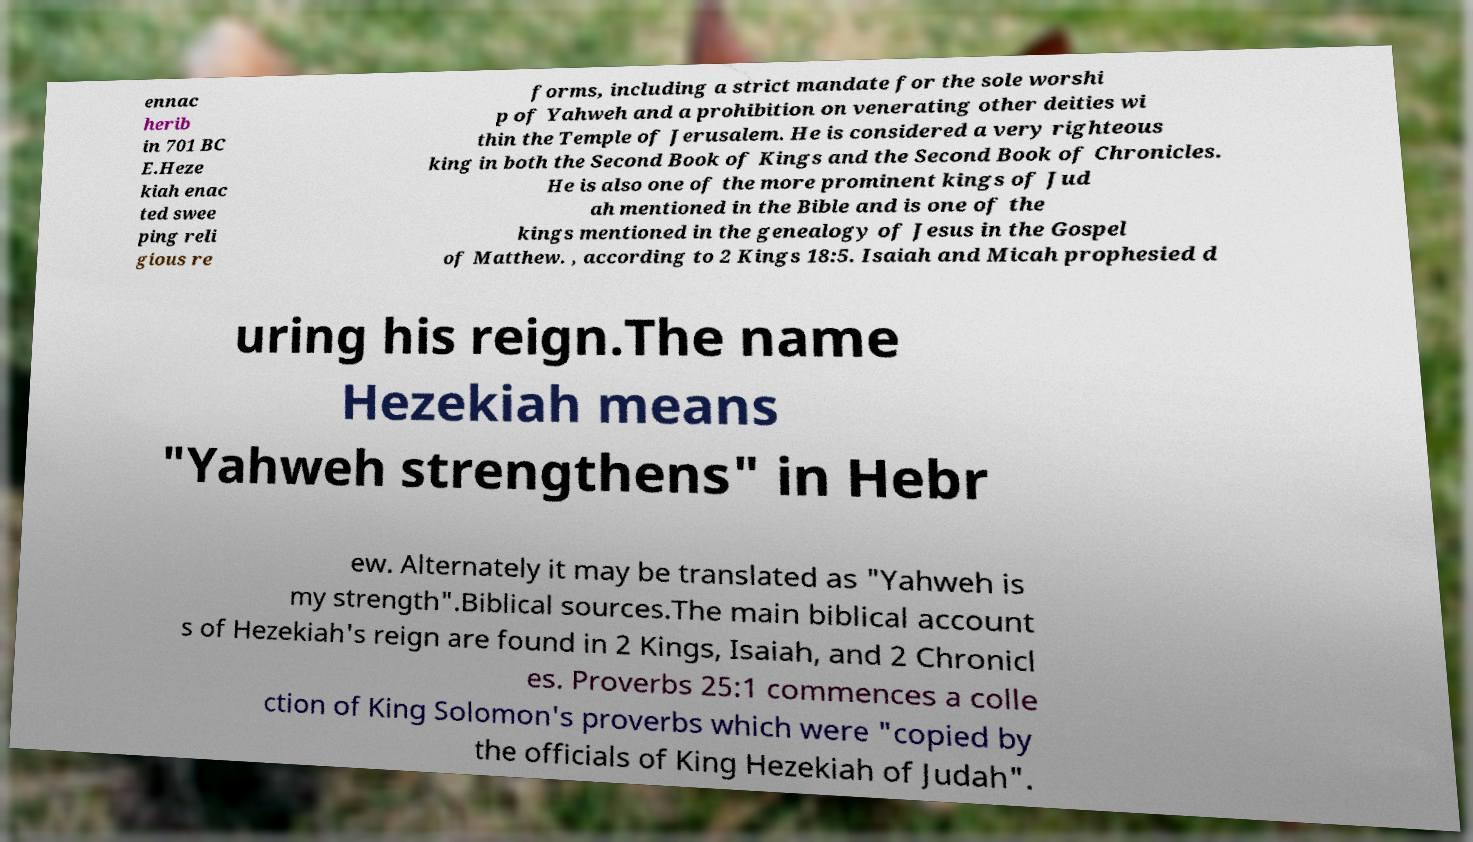Can you accurately transcribe the text from the provided image for me? ennac herib in 701 BC E.Heze kiah enac ted swee ping reli gious re forms, including a strict mandate for the sole worshi p of Yahweh and a prohibition on venerating other deities wi thin the Temple of Jerusalem. He is considered a very righteous king in both the Second Book of Kings and the Second Book of Chronicles. He is also one of the more prominent kings of Jud ah mentioned in the Bible and is one of the kings mentioned in the genealogy of Jesus in the Gospel of Matthew. , according to 2 Kings 18:5. Isaiah and Micah prophesied d uring his reign.The name Hezekiah means "Yahweh strengthens" in Hebr ew. Alternately it may be translated as "Yahweh is my strength".Biblical sources.The main biblical account s of Hezekiah's reign are found in 2 Kings, Isaiah, and 2 Chronicl es. Proverbs 25:1 commences a colle ction of King Solomon's proverbs which were "copied by the officials of King Hezekiah of Judah". 